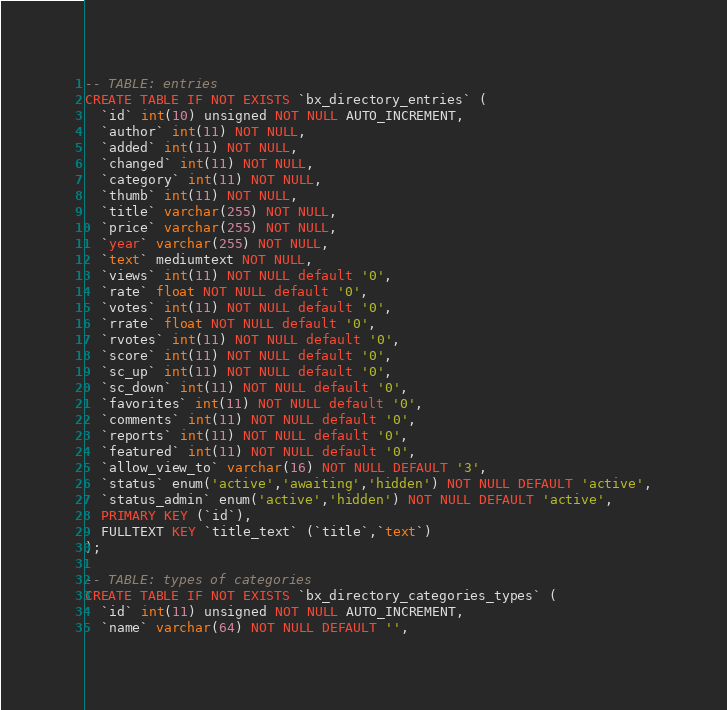<code> <loc_0><loc_0><loc_500><loc_500><_SQL_>-- TABLE: entries
CREATE TABLE IF NOT EXISTS `bx_directory_entries` (
  `id` int(10) unsigned NOT NULL AUTO_INCREMENT,
  `author` int(11) NOT NULL,
  `added` int(11) NOT NULL,
  `changed` int(11) NOT NULL,
  `category` int(11) NOT NULL,
  `thumb` int(11) NOT NULL,
  `title` varchar(255) NOT NULL,
  `price` varchar(255) NOT NULL,
  `year` varchar(255) NOT NULL,
  `text` mediumtext NOT NULL,
  `views` int(11) NOT NULL default '0',
  `rate` float NOT NULL default '0',
  `votes` int(11) NOT NULL default '0',
  `rrate` float NOT NULL default '0',
  `rvotes` int(11) NOT NULL default '0',
  `score` int(11) NOT NULL default '0',
  `sc_up` int(11) NOT NULL default '0',
  `sc_down` int(11) NOT NULL default '0',
  `favorites` int(11) NOT NULL default '0',
  `comments` int(11) NOT NULL default '0',
  `reports` int(11) NOT NULL default '0',
  `featured` int(11) NOT NULL default '0',
  `allow_view_to` varchar(16) NOT NULL DEFAULT '3',
  `status` enum('active','awaiting','hidden') NOT NULL DEFAULT 'active',
  `status_admin` enum('active','hidden') NOT NULL DEFAULT 'active',
  PRIMARY KEY (`id`),
  FULLTEXT KEY `title_text` (`title`,`text`)
);

-- TABLE: types of categories
CREATE TABLE IF NOT EXISTS `bx_directory_categories_types` (
  `id` int(11) unsigned NOT NULL AUTO_INCREMENT,
  `name` varchar(64) NOT NULL DEFAULT '',</code> 